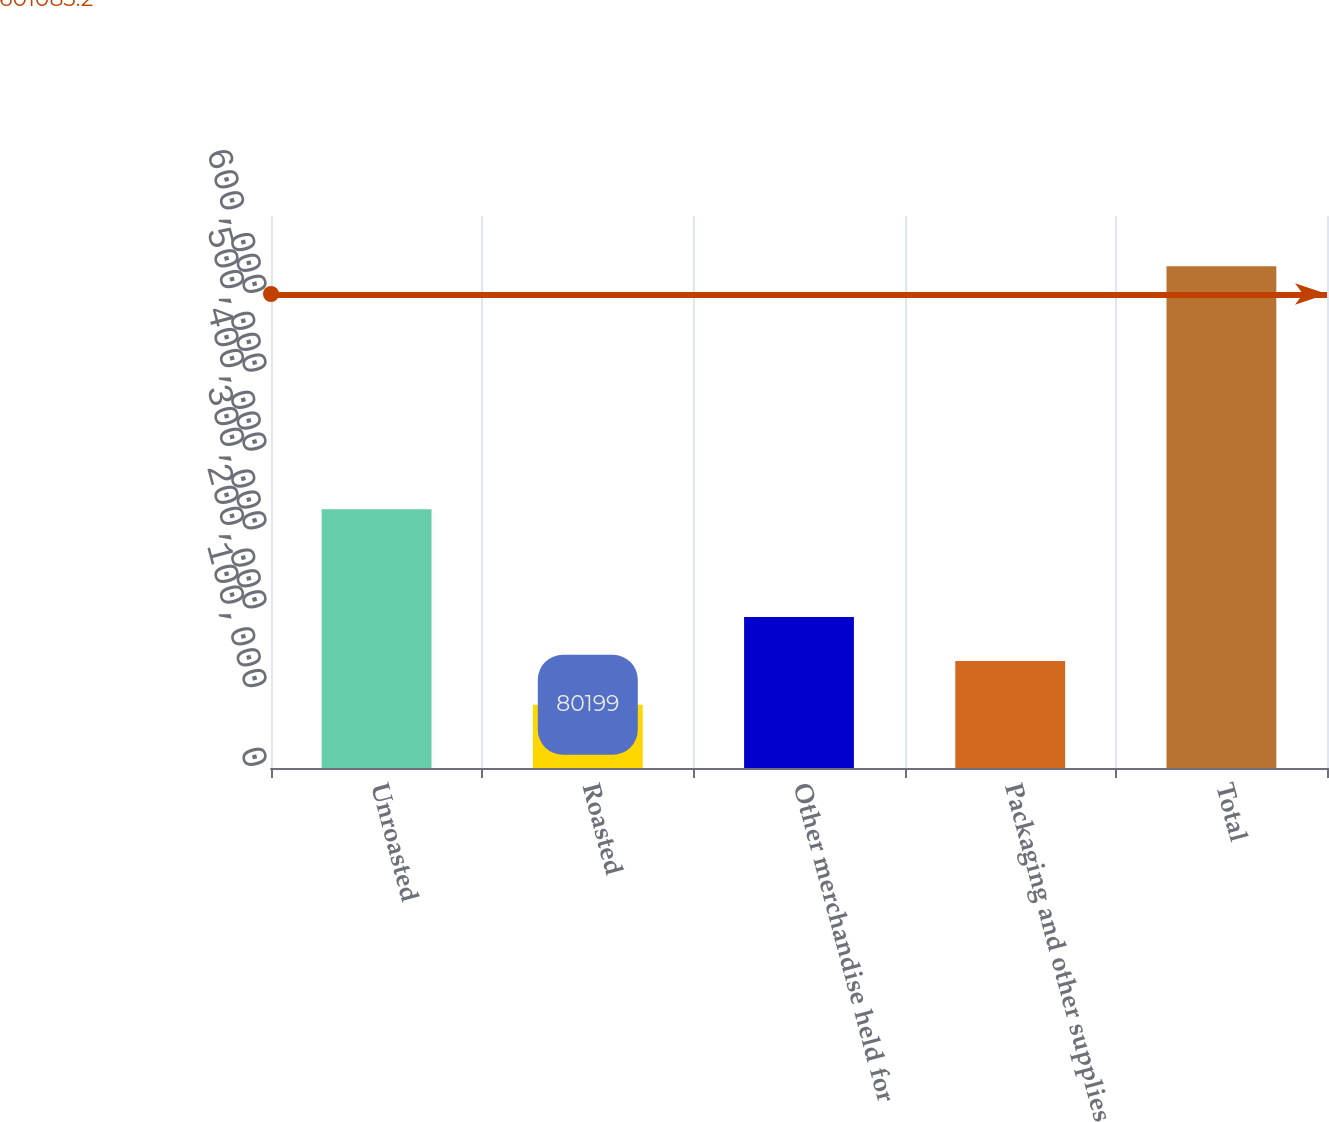Convert chart. <chart><loc_0><loc_0><loc_500><loc_500><bar_chart><fcel>Unroasted<fcel>Roasted<fcel>Other merchandise held for<fcel>Packaging and other supplies<fcel>Total<nl><fcel>328051<fcel>80199<fcel>191404<fcel>135801<fcel>636222<nl></chart> 